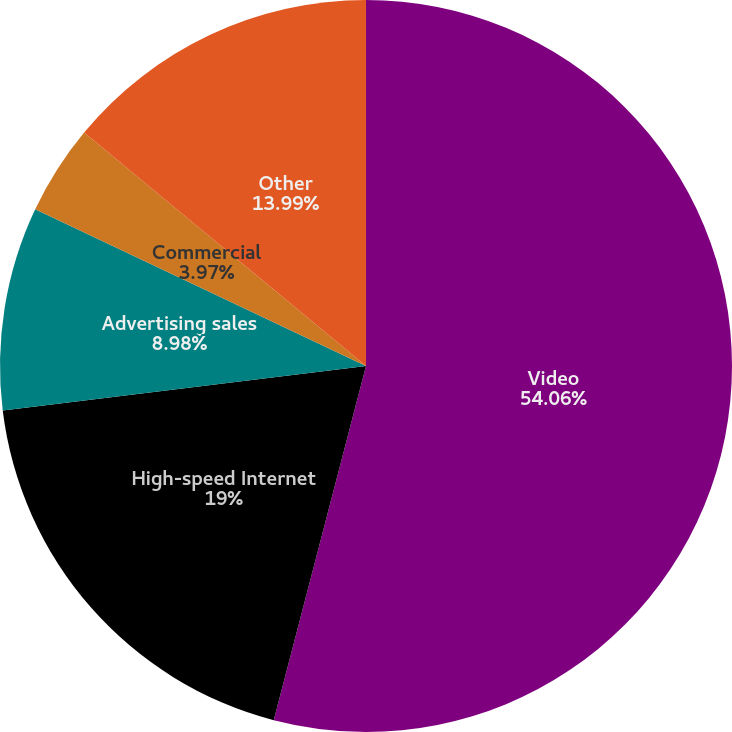Convert chart to OTSL. <chart><loc_0><loc_0><loc_500><loc_500><pie_chart><fcel>Video<fcel>High-speed Internet<fcel>Advertising sales<fcel>Commercial<fcel>Other<nl><fcel>54.05%<fcel>19.0%<fcel>8.98%<fcel>3.97%<fcel>13.99%<nl></chart> 